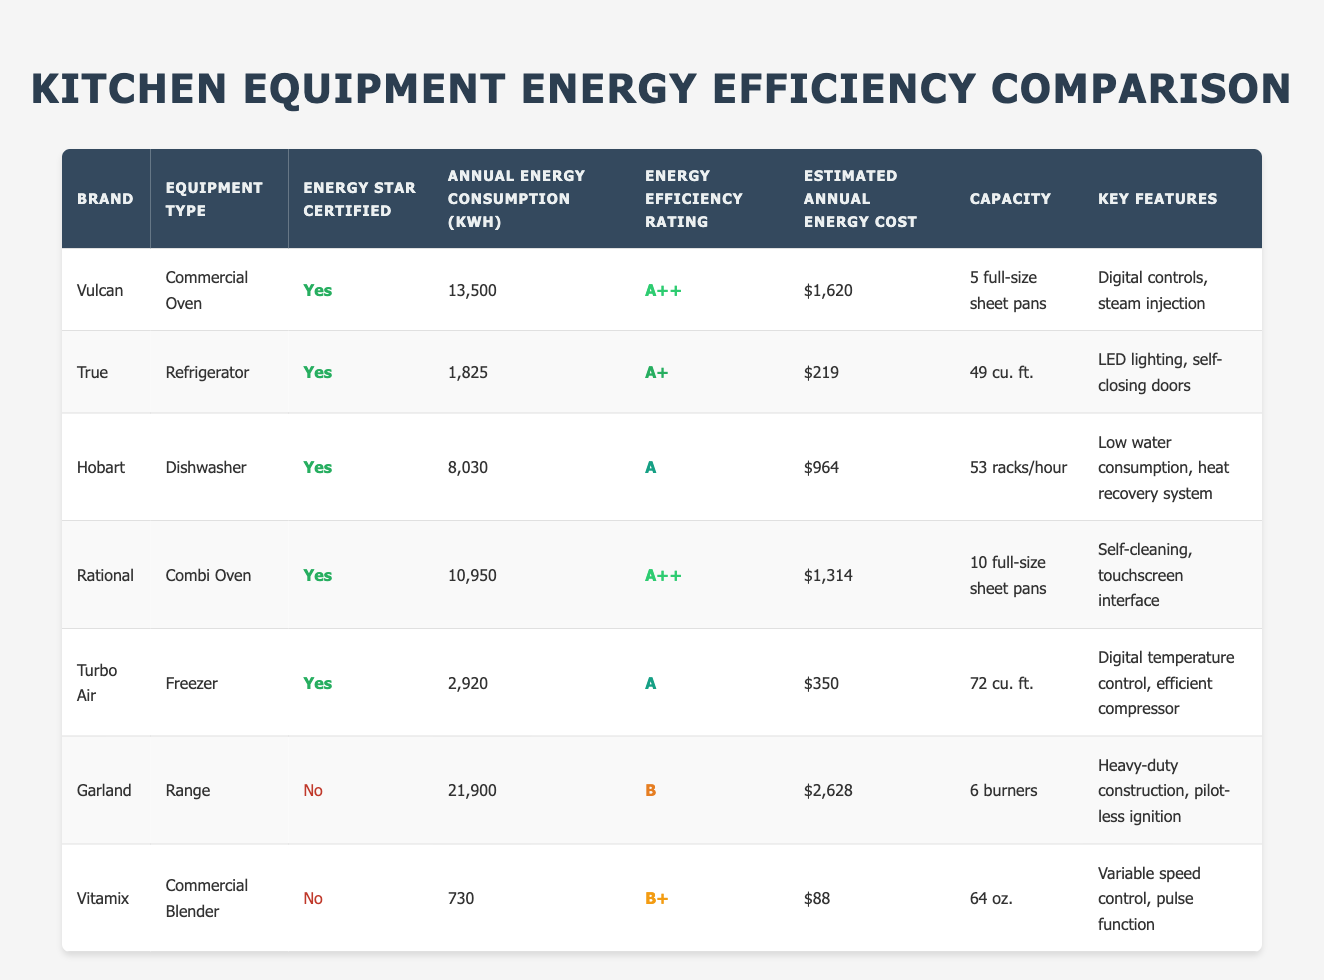What is the annual energy consumption of the True refrigerator? The annual energy consumption for the True refrigerator is listed in the table under the "Annual Energy Consumption (kWh)" column. It shows a value of 1,825 kWh.
Answer: 1,825 kWh Which brand has the highest energy efficiency rating? The highest energy efficiency rating in the table is "A++," which is listed for both Vulcan and Rational.
Answer: Vulcan and Rational Is the Garland range Energy Star certified? In the table, Garland is listed under the "Energy Star Certified" column, where it states "No," indicating it is not Energy Star certified.
Answer: No What is the estimated annual energy cost for the Hobart dishwasher? The estimated annual energy cost is found under the "Estimated Annual Energy Cost" column for Hobart, which indicates a value of $964.
Answer: $964 Calculate the total annual energy consumption of all Energy Star certified equipment types in the table. First, list the annual energy consumption for each Energy Star certified equipment: Vulcan (13,500 kWh), True (1,825 kWh), Hobart (8,030 kWh), Rational (10,950 kWh), Turbo Air (2,920 kWh). Then, sum these values: 13,500 + 1,825 + 8,030 + 10,950 + 2,920 = 37,225 kWh.
Answer: 37,225 kWh How many brands have an energy efficiency rating of A? The table indicates that Hobart and Turbo Air have an energy efficiency rating of A. Therefore, there are two brands with this rating.
Answer: 2 What is the capacity of the Rational combi oven? The capacity is found under the "Capacity" column for Rational, which states it can accommodate 10 full-size sheet pans.
Answer: 10 full-size sheet pans Which piece of equipment uses the least amount of annual energy? By comparing the "Annual Energy Consumption (kWh)" values, the Vitamix commercial blender has the lowest consumption listed at 730 kWh.
Answer: Vitamix commercial blender Are all refrigerators in the table Energy Star certified? In the table, only the True refrigerator is marked as Energy Star certified, while there is no mention of certification for other types of refrigerators. Hence, the statement is false.
Answer: No 